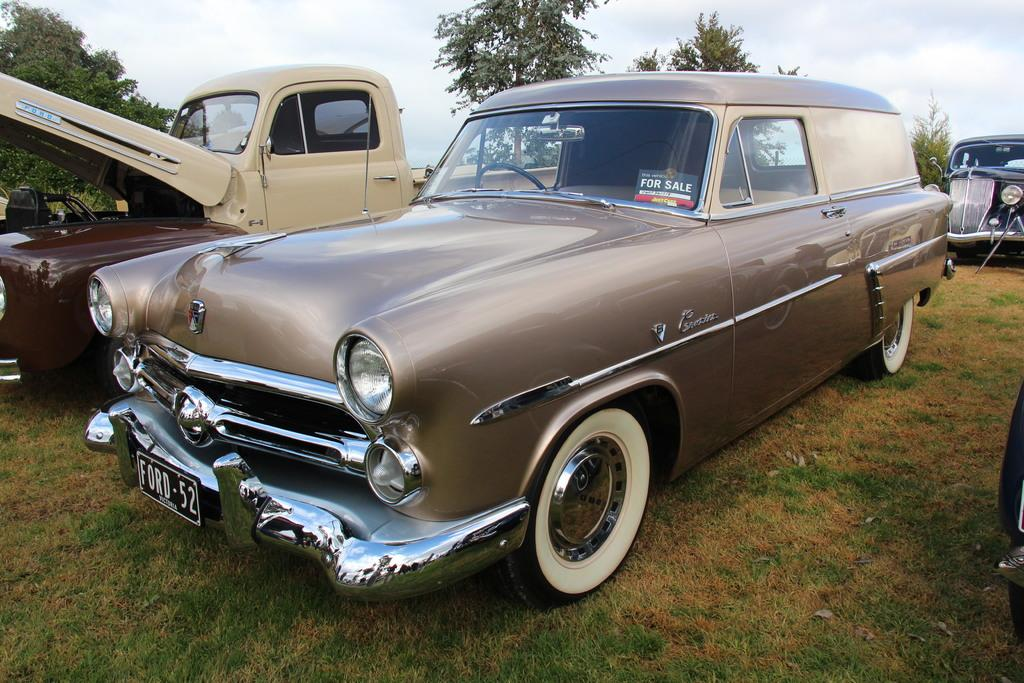Provide a one-sentence caption for the provided image. An old Ford car with the license plate Ford 52 parked next to another vehicle with the hood up. 